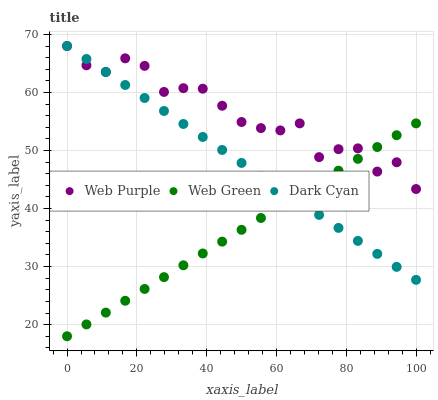Does Web Green have the minimum area under the curve?
Answer yes or no. Yes. Does Web Purple have the maximum area under the curve?
Answer yes or no. Yes. Does Web Purple have the minimum area under the curve?
Answer yes or no. No. Does Web Green have the maximum area under the curve?
Answer yes or no. No. Is Dark Cyan the smoothest?
Answer yes or no. Yes. Is Web Purple the roughest?
Answer yes or no. Yes. Is Web Green the smoothest?
Answer yes or no. No. Is Web Green the roughest?
Answer yes or no. No. Does Web Green have the lowest value?
Answer yes or no. Yes. Does Web Purple have the lowest value?
Answer yes or no. No. Does Web Purple have the highest value?
Answer yes or no. Yes. Does Web Green have the highest value?
Answer yes or no. No. Does Web Purple intersect Dark Cyan?
Answer yes or no. Yes. Is Web Purple less than Dark Cyan?
Answer yes or no. No. Is Web Purple greater than Dark Cyan?
Answer yes or no. No. 